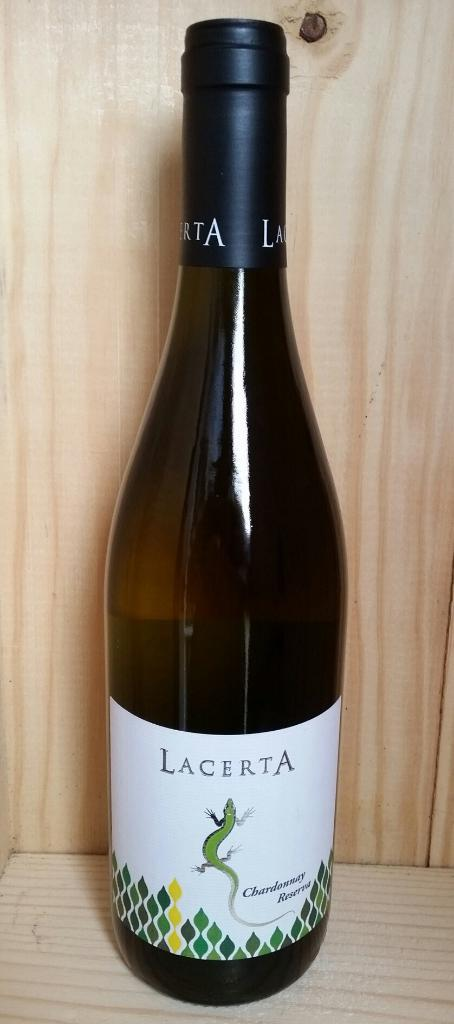<image>
Give a short and clear explanation of the subsequent image. Bottle of Lacerta wine that is brand new 